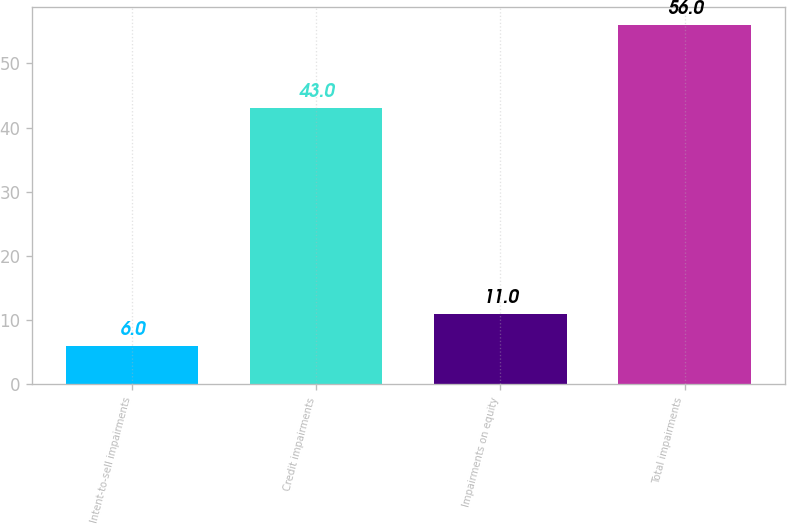Convert chart. <chart><loc_0><loc_0><loc_500><loc_500><bar_chart><fcel>Intent-to-sell impairments<fcel>Credit impairments<fcel>Impairments on equity<fcel>Total impairments<nl><fcel>6<fcel>43<fcel>11<fcel>56<nl></chart> 